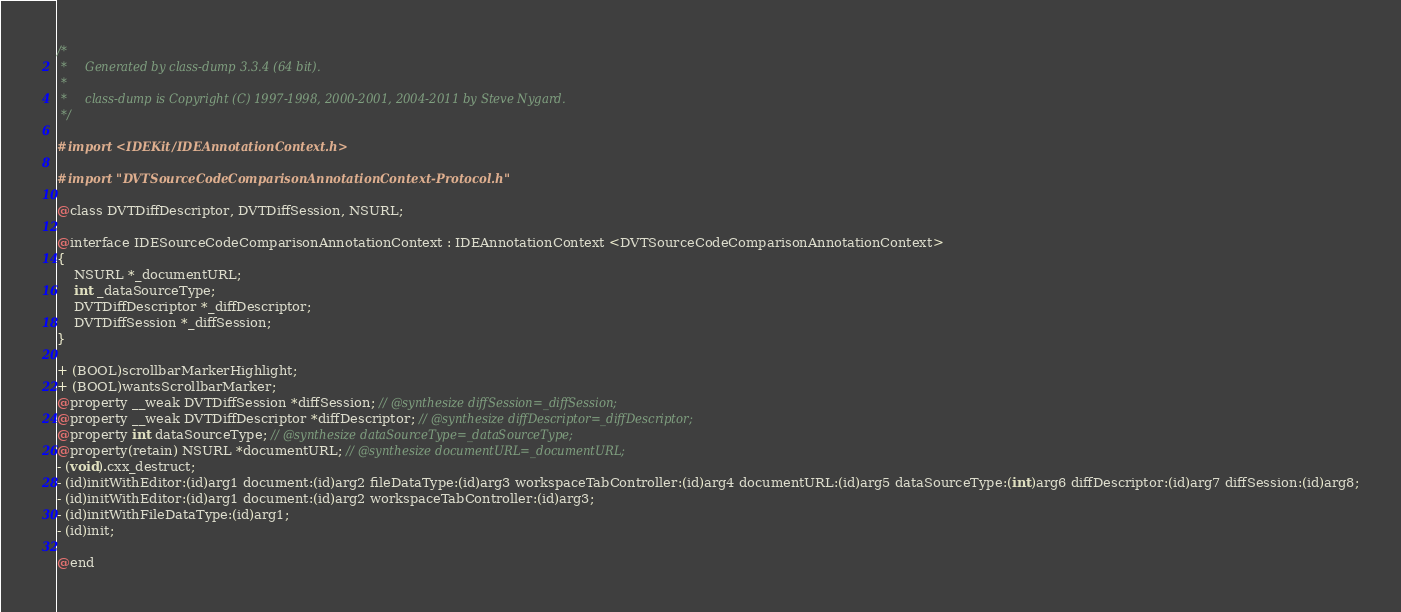<code> <loc_0><loc_0><loc_500><loc_500><_C_>/*
 *     Generated by class-dump 3.3.4 (64 bit).
 *
 *     class-dump is Copyright (C) 1997-1998, 2000-2001, 2004-2011 by Steve Nygard.
 */

#import <IDEKit/IDEAnnotationContext.h>

#import "DVTSourceCodeComparisonAnnotationContext-Protocol.h"

@class DVTDiffDescriptor, DVTDiffSession, NSURL;

@interface IDESourceCodeComparisonAnnotationContext : IDEAnnotationContext <DVTSourceCodeComparisonAnnotationContext>
{
    NSURL *_documentURL;
    int _dataSourceType;
    DVTDiffDescriptor *_diffDescriptor;
    DVTDiffSession *_diffSession;
}

+ (BOOL)scrollbarMarkerHighlight;
+ (BOOL)wantsScrollbarMarker;
@property __weak DVTDiffSession *diffSession; // @synthesize diffSession=_diffSession;
@property __weak DVTDiffDescriptor *diffDescriptor; // @synthesize diffDescriptor=_diffDescriptor;
@property int dataSourceType; // @synthesize dataSourceType=_dataSourceType;
@property(retain) NSURL *documentURL; // @synthesize documentURL=_documentURL;
- (void).cxx_destruct;
- (id)initWithEditor:(id)arg1 document:(id)arg2 fileDataType:(id)arg3 workspaceTabController:(id)arg4 documentURL:(id)arg5 dataSourceType:(int)arg6 diffDescriptor:(id)arg7 diffSession:(id)arg8;
- (id)initWithEditor:(id)arg1 document:(id)arg2 workspaceTabController:(id)arg3;
- (id)initWithFileDataType:(id)arg1;
- (id)init;

@end

</code> 